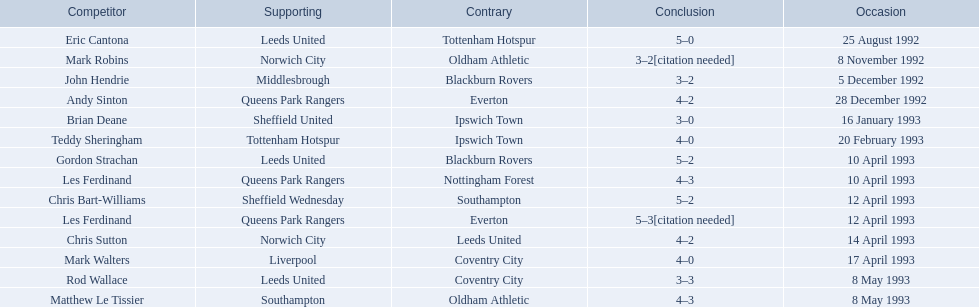Who are all the players? Eric Cantona, Mark Robins, John Hendrie, Andy Sinton, Brian Deane, Teddy Sheringham, Gordon Strachan, Les Ferdinand, Chris Bart-Williams, Les Ferdinand, Chris Sutton, Mark Walters, Rod Wallace, Matthew Le Tissier. What were their results? 5–0, 3–2[citation needed], 3–2, 4–2, 3–0, 4–0, 5–2, 4–3, 5–2, 5–3[citation needed], 4–2, 4–0, 3–3, 4–3. Which player tied with mark robins? John Hendrie. 